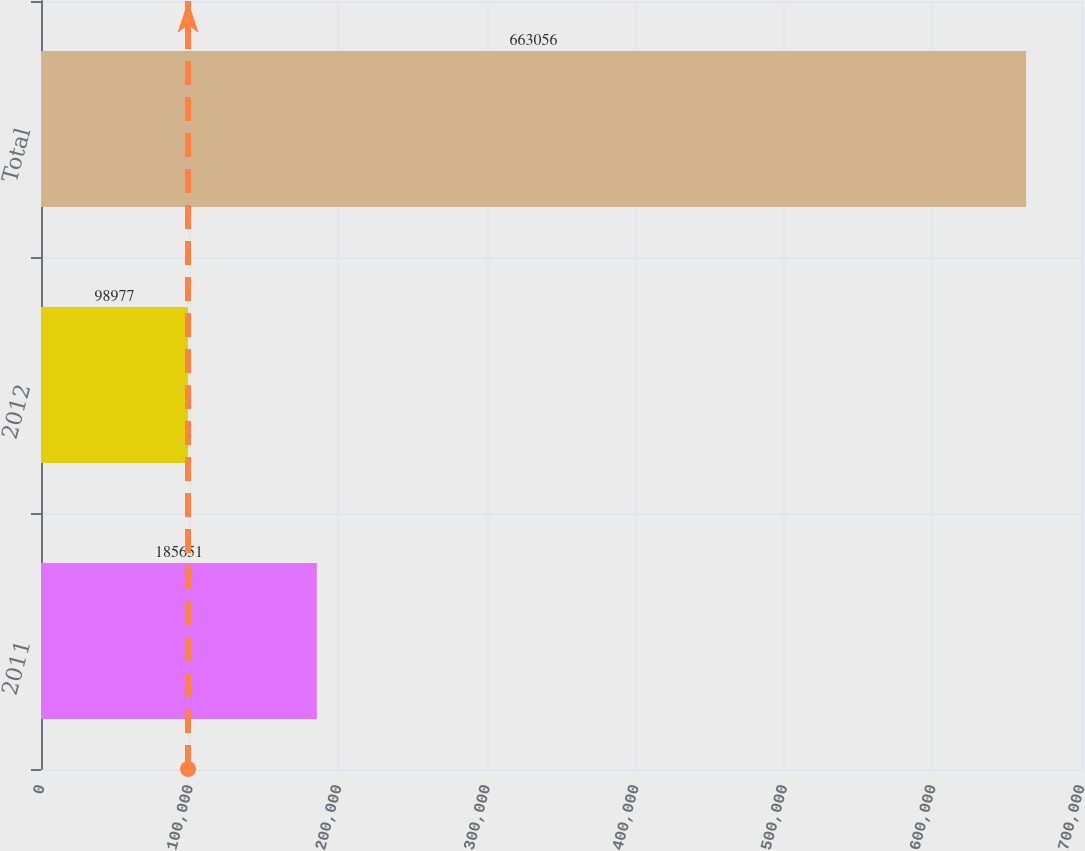Convert chart. <chart><loc_0><loc_0><loc_500><loc_500><bar_chart><fcel>2011<fcel>2012<fcel>Total<nl><fcel>185651<fcel>98977<fcel>663056<nl></chart> 